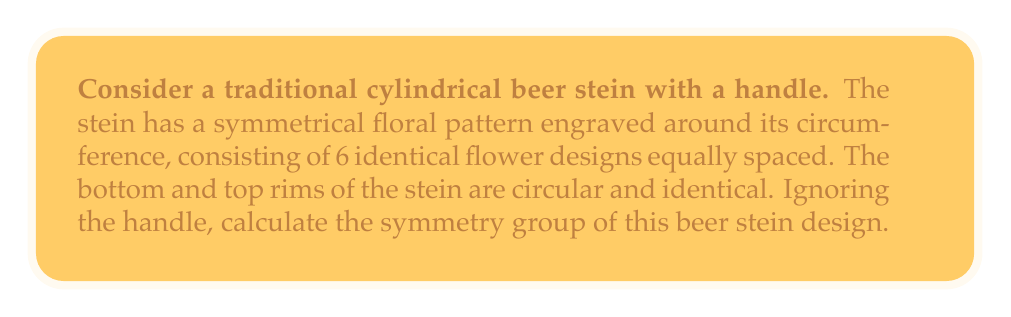Can you solve this math problem? To determine the symmetry group of the beer stein design, we need to consider all the symmetry operations that leave the design unchanged. Let's approach this step-by-step:

1. Rotational symmetry:
   The stein has 6 identical flower designs equally spaced around its circumference. This means it has 6-fold rotational symmetry about its central vertical axis. The rotations are:
   $$\{e, r, r^2, r^3, r^4, r^5\}$$
   where $e$ is the identity and $r$ is a rotation by $60^\circ$.

2. Reflection symmetry:
   There are 6 vertical planes of reflection symmetry, each passing through the center of a flower and the stein's central axis. Let's call these reflections $\{m_1, m_2, m_3, m_4, m_5, m_6\}$.

3. Horizontal reflection:
   Since the top and bottom rims are identical, there is also a horizontal reflection symmetry through the middle of the stein. Let's call this $h$.

4. Improper rotations:
   The combination of rotations and the horizontal reflection produces 6 improper rotations (rotoreflections). These can be represented as $\{hr, hr^2, hr^3, hr^4, hr^5, h\}$.

The total number of symmetry operations is therefore:
6 (rotations) + 6 (vertical reflections) + 1 (horizontal reflection) + 6 (improper rotations) = 19

This collection of symmetry operations forms a group under composition. The structure of this group is that of the dihedral group $D_6$ (order 12) combined with a horizontal reflection, which doubles the order of the group.

This symmetry group is isomorphic to $D_6 \times C_2$, where $D_6$ is the dihedral group of order 12 and $C_2$ is the cyclic group of order 2.
Answer: The symmetry group of the beer stein design is $D_6 \times C_2$, of order 24. 